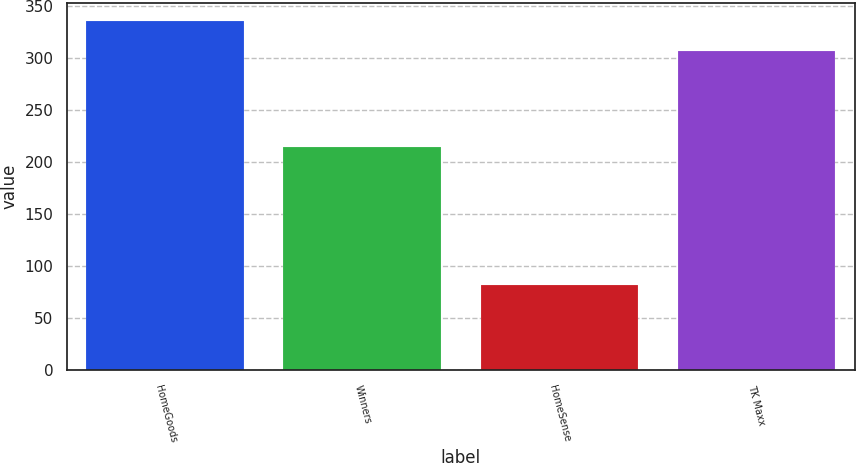Convert chart. <chart><loc_0><loc_0><loc_500><loc_500><bar_chart><fcel>HomeGoods<fcel>Winners<fcel>HomeSense<fcel>TK Maxx<nl><fcel>336<fcel>215<fcel>82<fcel>307<nl></chart> 